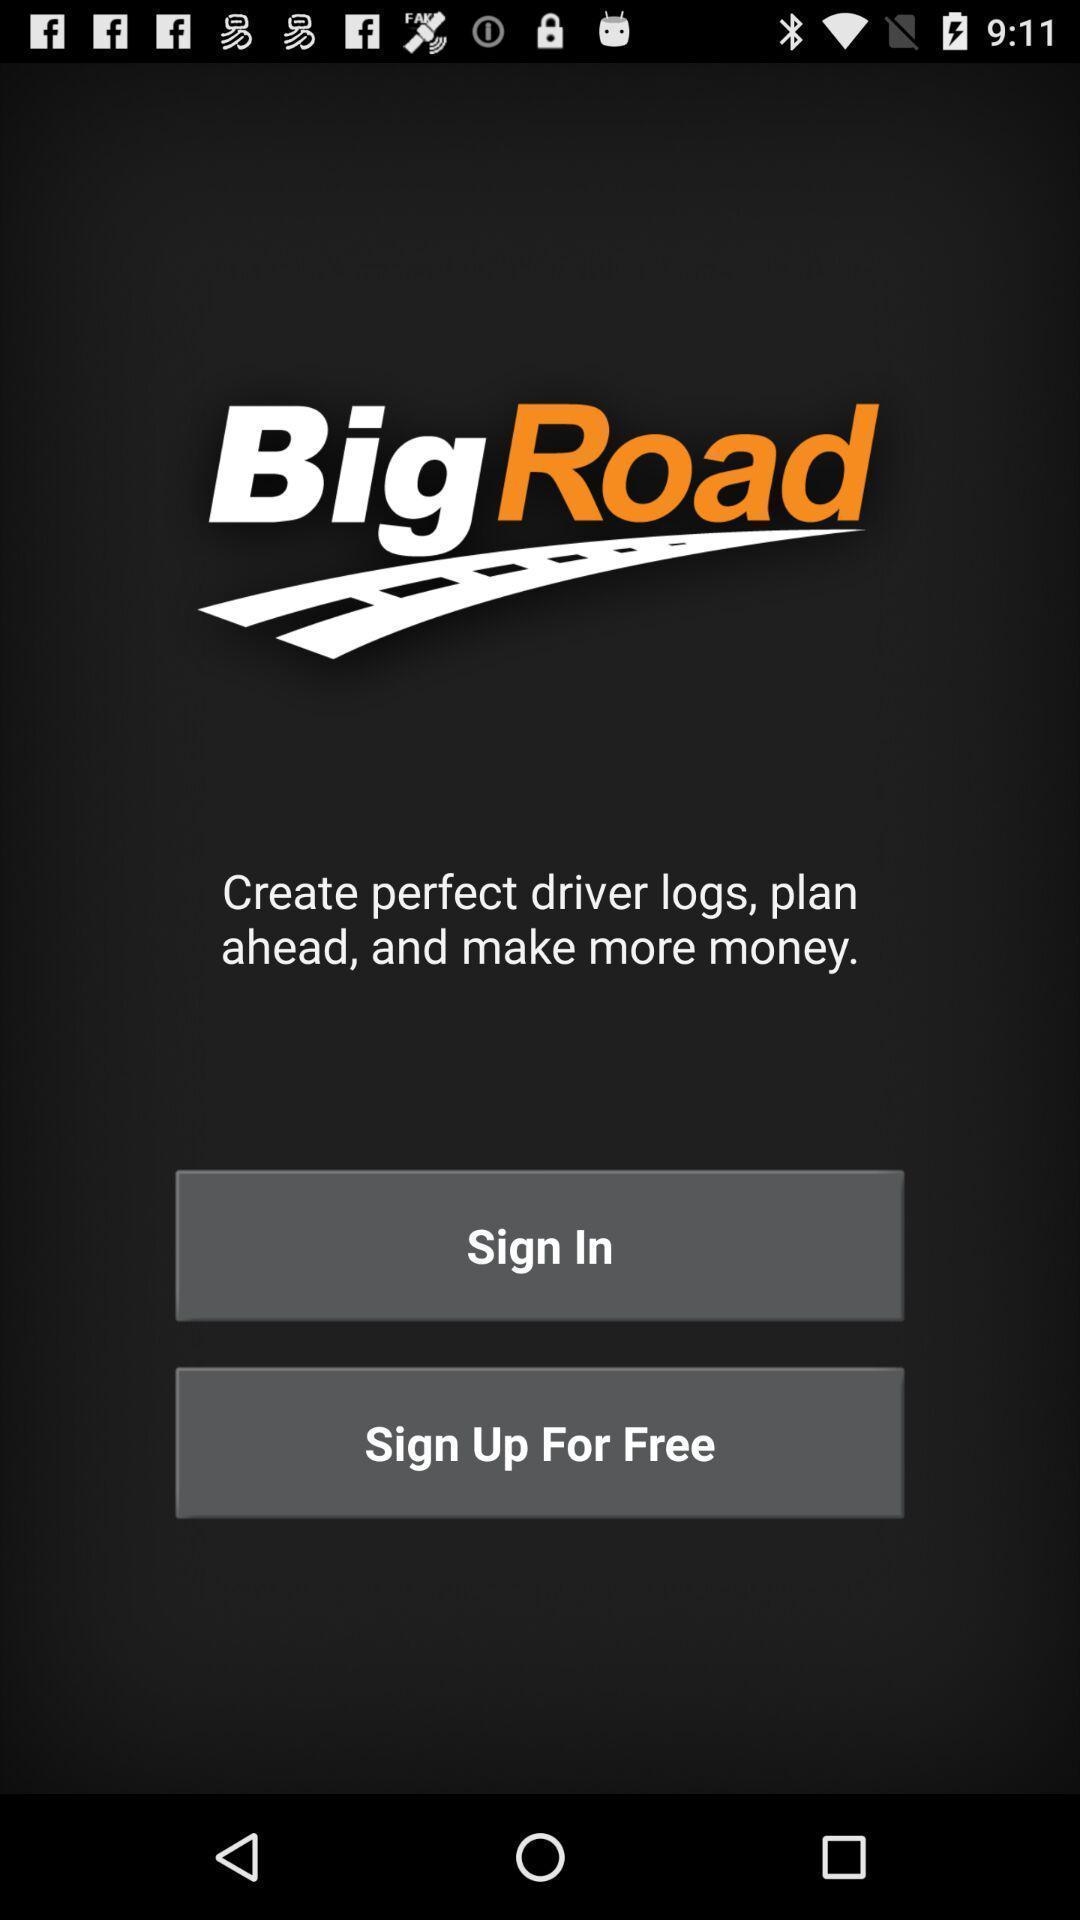What details can you identify in this image? Sign in page. 